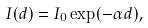Convert formula to latex. <formula><loc_0><loc_0><loc_500><loc_500>I ( d ) = I _ { 0 } \exp ( - \alpha d ) ,</formula> 